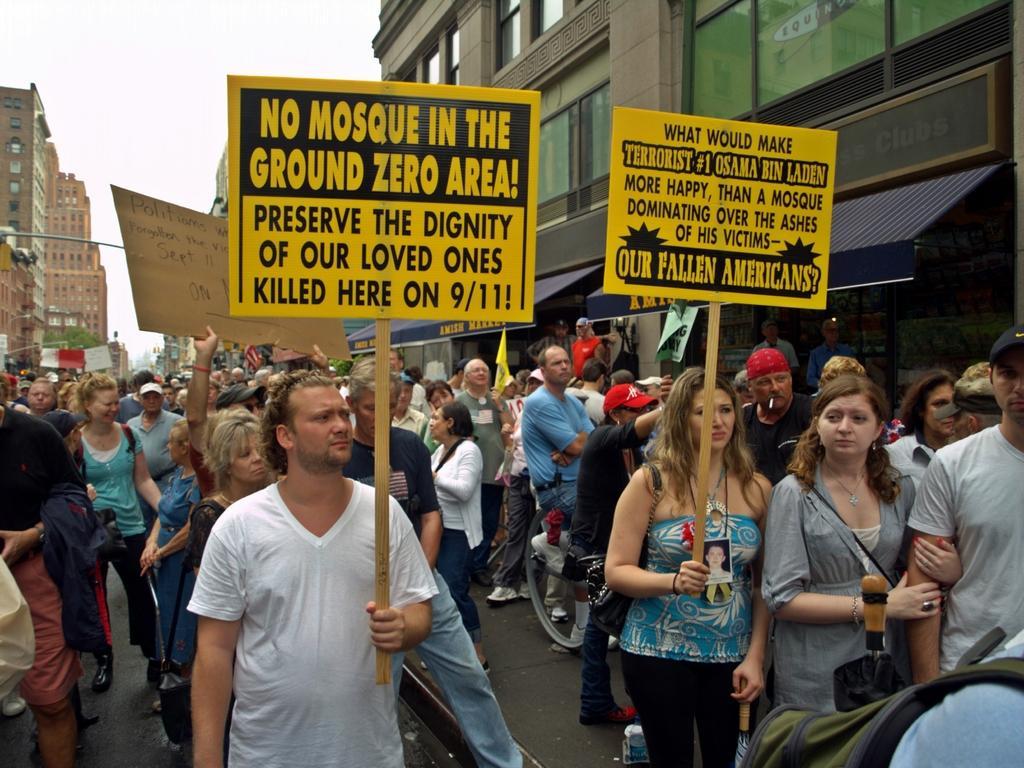Please provide a concise description of this image. In this image, on the right there is a woman, she is holding a stick, board. On the left there is a man, he is holding a stick and board. In the background there are many people, vehicles, posters, chats, text, streetlight, pole, buildings, road, sky. 